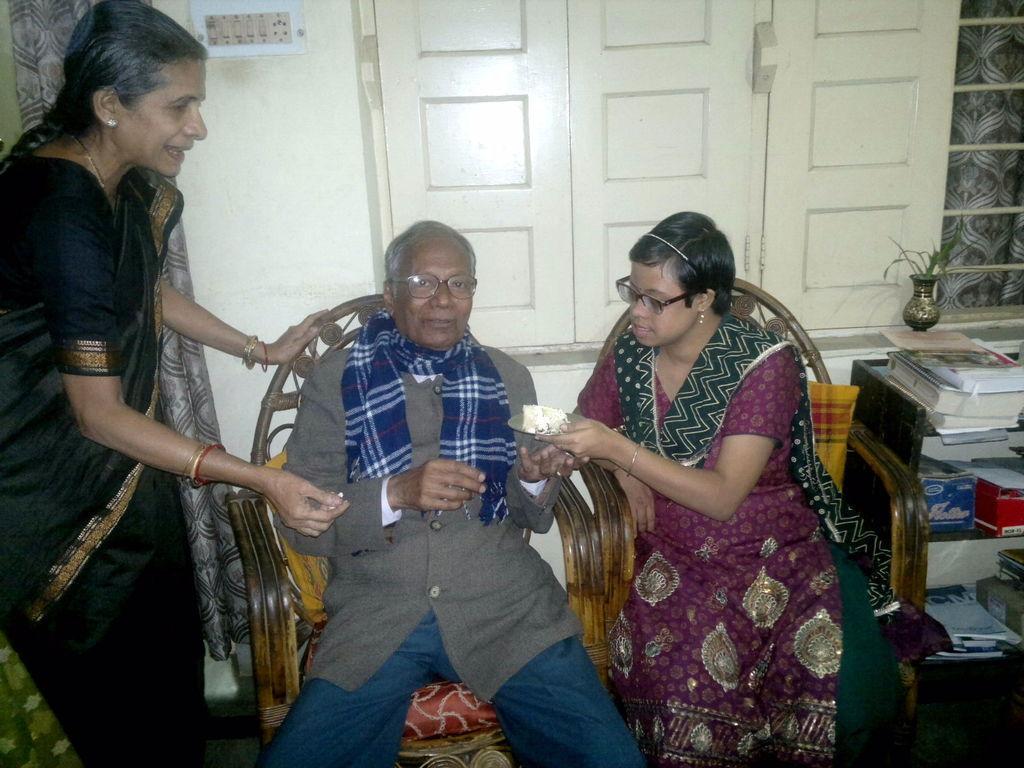How would you summarize this image in a sentence or two? In this image I can see three persons, the person at right is wearing green and pink color dress and the person at left is wearing black color saree. Background I can see few books in the racks and I can see the window and the wall is in white color. 